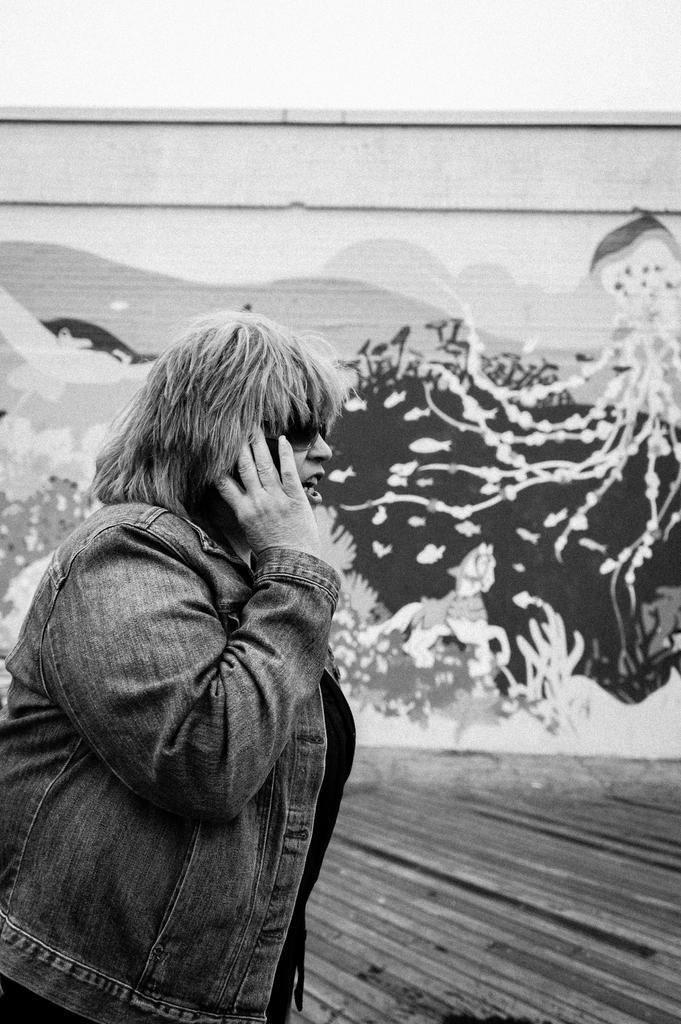How would you summarize this image in a sentence or two? This is a black and white image. We can see a person. Behind the person, there is a painting on the wall. At the top of the image, it looks like the sky. 